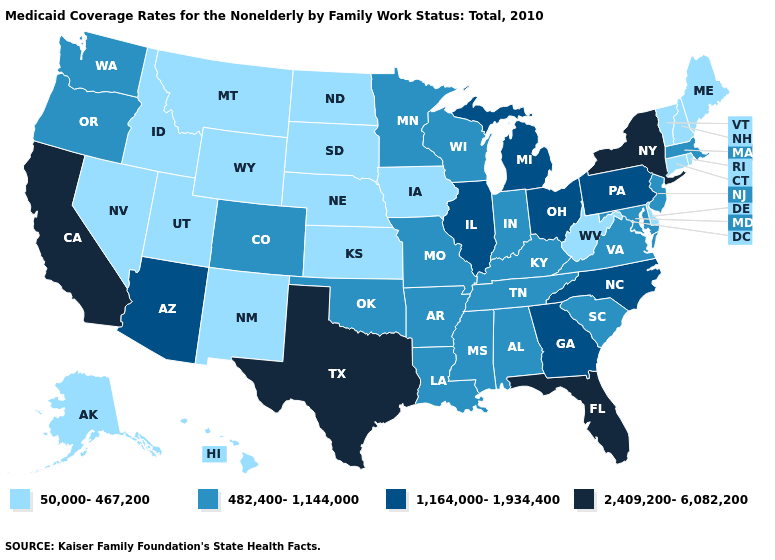Does Kentucky have a lower value than Georgia?
Give a very brief answer. Yes. Name the states that have a value in the range 2,409,200-6,082,200?
Write a very short answer. California, Florida, New York, Texas. Does the first symbol in the legend represent the smallest category?
Concise answer only. Yes. Among the states that border New Hampshire , which have the lowest value?
Short answer required. Maine, Vermont. What is the value of Colorado?
Be succinct. 482,400-1,144,000. Name the states that have a value in the range 50,000-467,200?
Give a very brief answer. Alaska, Connecticut, Delaware, Hawaii, Idaho, Iowa, Kansas, Maine, Montana, Nebraska, Nevada, New Hampshire, New Mexico, North Dakota, Rhode Island, South Dakota, Utah, Vermont, West Virginia, Wyoming. Among the states that border Iowa , does South Dakota have the lowest value?
Answer briefly. Yes. Name the states that have a value in the range 1,164,000-1,934,400?
Short answer required. Arizona, Georgia, Illinois, Michigan, North Carolina, Ohio, Pennsylvania. Name the states that have a value in the range 2,409,200-6,082,200?
Quick response, please. California, Florida, New York, Texas. What is the lowest value in the USA?
Write a very short answer. 50,000-467,200. What is the value of Michigan?
Short answer required. 1,164,000-1,934,400. Among the states that border Vermont , does Massachusetts have the highest value?
Answer briefly. No. What is the lowest value in states that border North Carolina?
Write a very short answer. 482,400-1,144,000. What is the value of Iowa?
Concise answer only. 50,000-467,200. How many symbols are there in the legend?
Answer briefly. 4. 